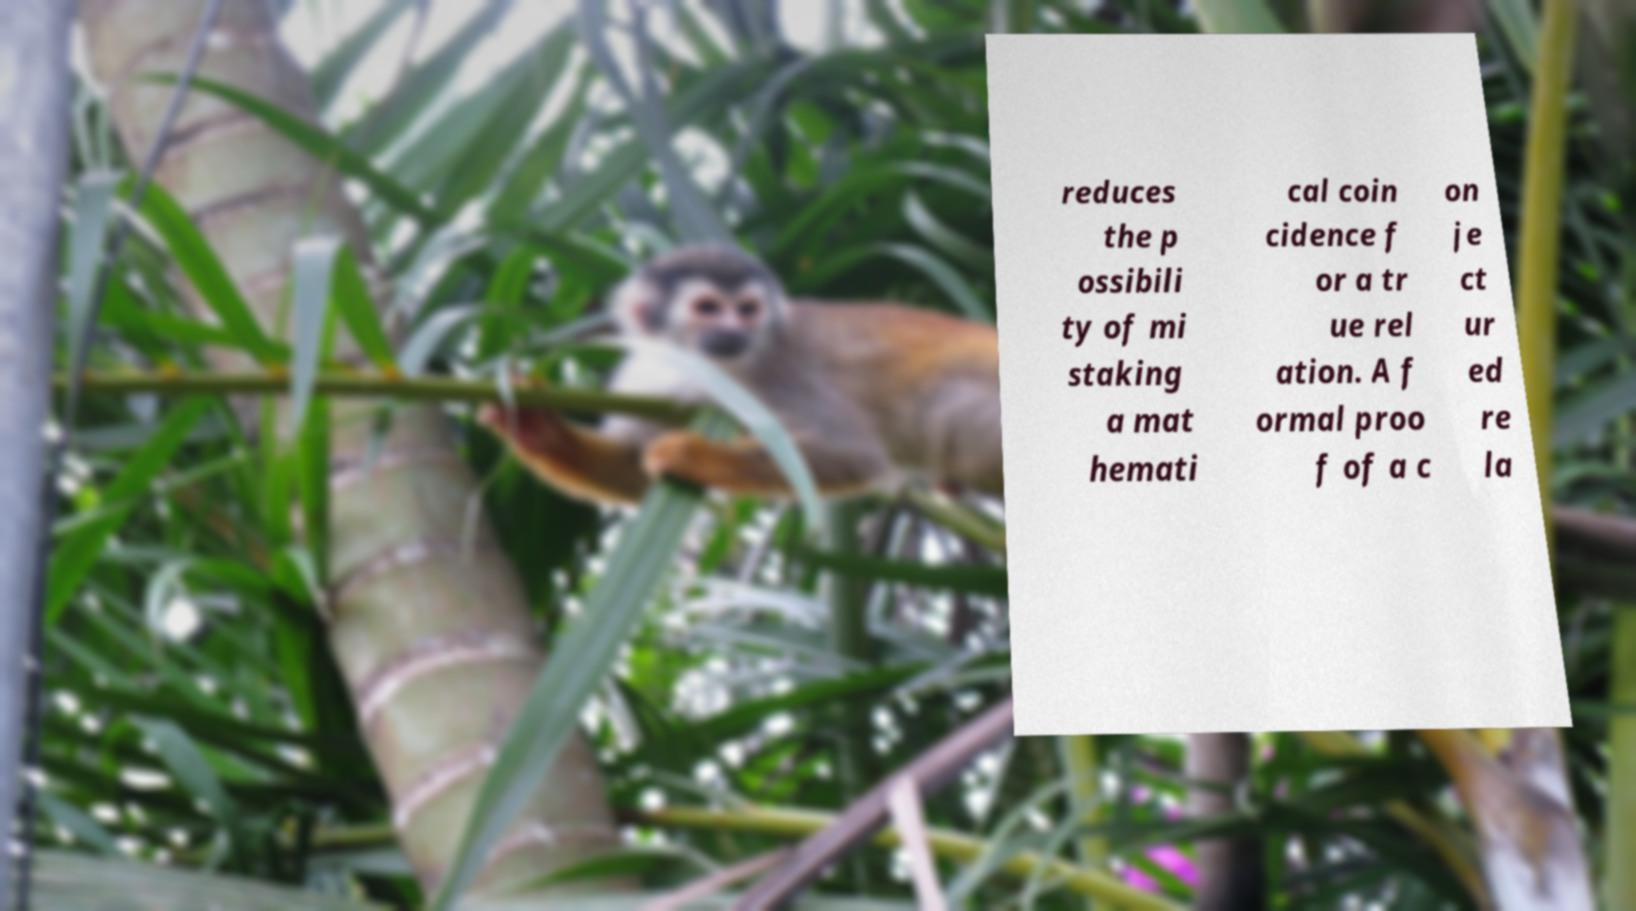There's text embedded in this image that I need extracted. Can you transcribe it verbatim? reduces the p ossibili ty of mi staking a mat hemati cal coin cidence f or a tr ue rel ation. A f ormal proo f of a c on je ct ur ed re la 